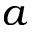Convert formula to latex. <formula><loc_0><loc_0><loc_500><loc_500>a</formula> 